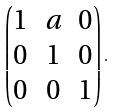<formula> <loc_0><loc_0><loc_500><loc_500>\begin{pmatrix} 1 & a & 0 \\ 0 & 1 & 0 \\ 0 & 0 & 1 \end{pmatrix} .</formula> 